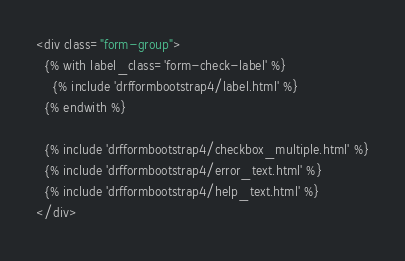Convert code to text. <code><loc_0><loc_0><loc_500><loc_500><_HTML_><div class="form-group">
  {% with label_class='form-check-label' %}
    {% include 'drfformbootstrap4/label.html' %}
  {% endwith %}

  {% include 'drfformbootstrap4/checkbox_multiple.html' %}
  {% include 'drfformbootstrap4/error_text.html' %}
  {% include 'drfformbootstrap4/help_text.html' %}
</div>
</code> 